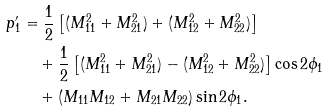<formula> <loc_0><loc_0><loc_500><loc_500>p _ { 1 } ^ { \prime } & = \frac { 1 } { 2 } \left [ ( M _ { 1 1 } ^ { 2 } + M _ { 2 1 } ^ { 2 } ) + ( M _ { 1 2 } ^ { 2 } + M _ { 2 2 } ^ { 2 } ) \right ] \\ & \quad + \frac { 1 } { 2 } \left [ ( M _ { 1 1 } ^ { 2 } + M _ { 2 1 } ^ { 2 } ) - ( M _ { 1 2 } ^ { 2 } + M _ { 2 2 } ^ { 2 } ) \right ] \cos 2 \phi _ { 1 } \\ & \quad + \left ( M _ { 1 1 } M _ { 1 2 } + M _ { 2 1 } M _ { 2 2 } \right ) \sin 2 \phi _ { 1 } .</formula> 